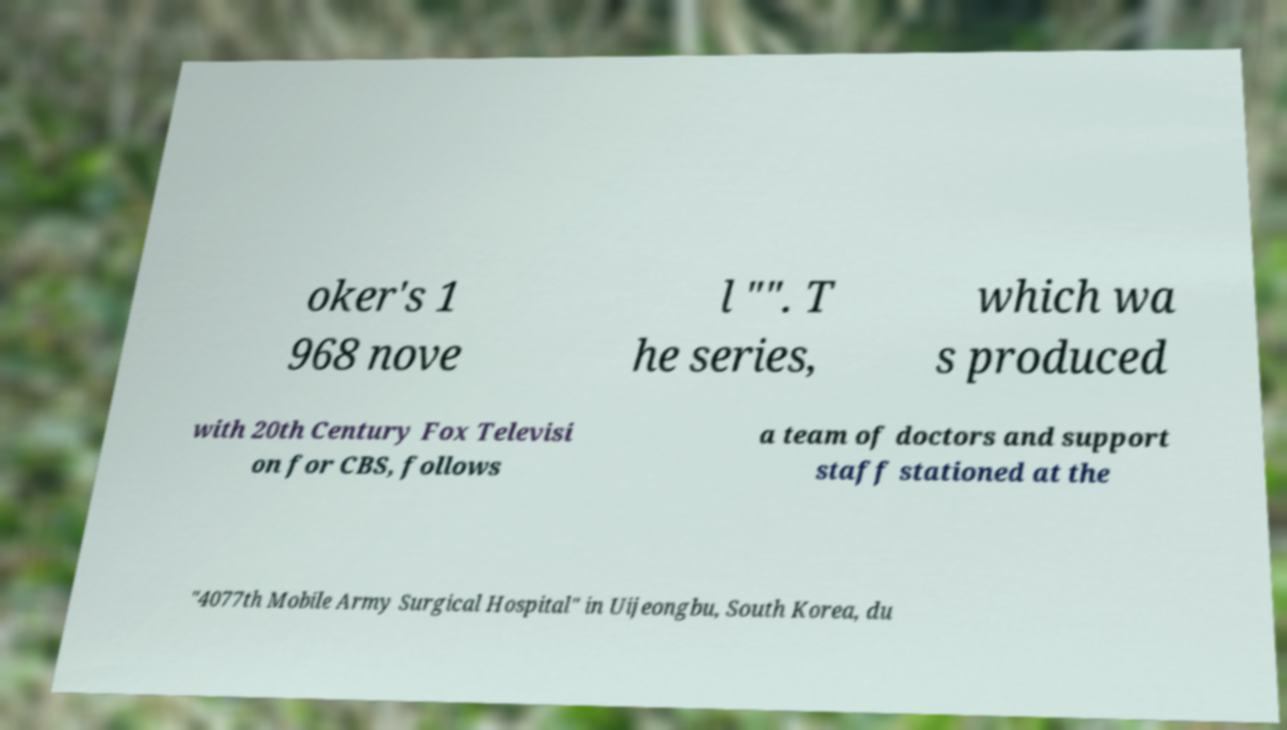For documentation purposes, I need the text within this image transcribed. Could you provide that? oker's 1 968 nove l "". T he series, which wa s produced with 20th Century Fox Televisi on for CBS, follows a team of doctors and support staff stationed at the "4077th Mobile Army Surgical Hospital" in Uijeongbu, South Korea, du 